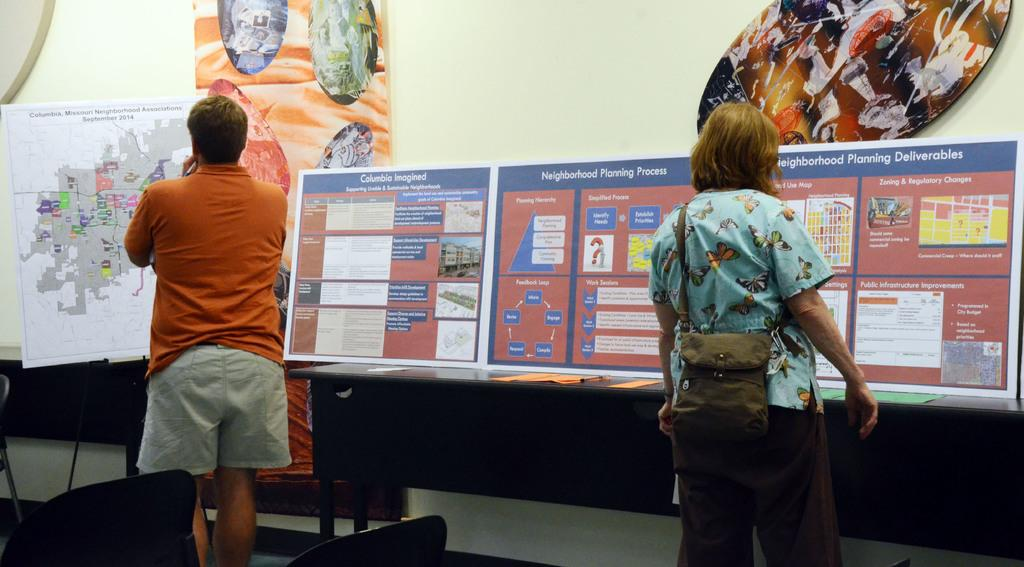How many people are in the image? There are two persons in the image. What are the two persons doing in the image? The two persons are standing and looking at posters. What type of linen is draped over the hall in the image? There is no linen or hall present in the image; it features two persons standing and looking at posters. How many nets are visible in the image? There are no nets visible in the image. 